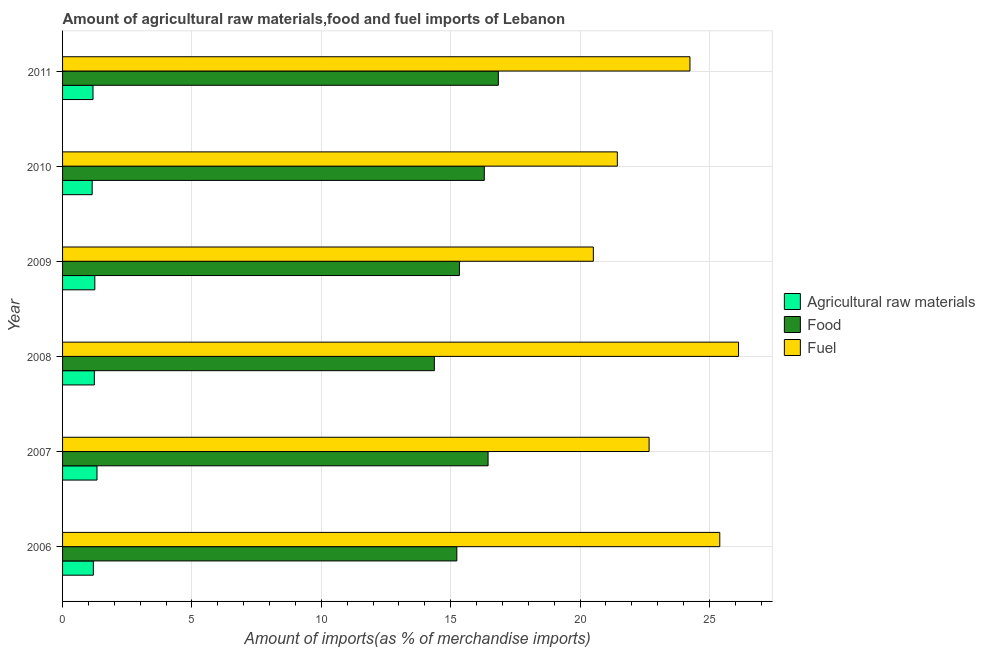How many different coloured bars are there?
Your response must be concise. 3. How many groups of bars are there?
Offer a terse response. 6. Are the number of bars on each tick of the Y-axis equal?
Offer a very short reply. Yes. How many bars are there on the 6th tick from the bottom?
Offer a very short reply. 3. What is the label of the 1st group of bars from the top?
Offer a terse response. 2011. What is the percentage of raw materials imports in 2006?
Give a very brief answer. 1.19. Across all years, what is the maximum percentage of fuel imports?
Offer a very short reply. 26.12. Across all years, what is the minimum percentage of fuel imports?
Keep it short and to the point. 20.51. What is the total percentage of food imports in the graph?
Ensure brevity in your answer.  94.52. What is the difference between the percentage of food imports in 2007 and that in 2011?
Your answer should be compact. -0.4. What is the difference between the percentage of food imports in 2006 and the percentage of raw materials imports in 2007?
Provide a succinct answer. 13.91. What is the average percentage of food imports per year?
Your answer should be very brief. 15.75. In the year 2007, what is the difference between the percentage of raw materials imports and percentage of fuel imports?
Provide a succinct answer. -21.34. What is the ratio of the percentage of food imports in 2006 to that in 2007?
Ensure brevity in your answer.  0.93. What is the difference between the highest and the second highest percentage of raw materials imports?
Give a very brief answer. 0.08. What is the difference between the highest and the lowest percentage of raw materials imports?
Make the answer very short. 0.19. In how many years, is the percentage of fuel imports greater than the average percentage of fuel imports taken over all years?
Your answer should be very brief. 3. Is the sum of the percentage of food imports in 2009 and 2011 greater than the maximum percentage of fuel imports across all years?
Keep it short and to the point. Yes. What does the 1st bar from the top in 2007 represents?
Offer a very short reply. Fuel. What does the 2nd bar from the bottom in 2007 represents?
Offer a very short reply. Food. How many bars are there?
Make the answer very short. 18. What is the difference between two consecutive major ticks on the X-axis?
Offer a terse response. 5. Does the graph contain any zero values?
Ensure brevity in your answer.  No. Does the graph contain grids?
Provide a succinct answer. Yes. How are the legend labels stacked?
Give a very brief answer. Vertical. What is the title of the graph?
Your answer should be compact. Amount of agricultural raw materials,food and fuel imports of Lebanon. Does "Negligence towards kids" appear as one of the legend labels in the graph?
Make the answer very short. No. What is the label or title of the X-axis?
Your answer should be compact. Amount of imports(as % of merchandise imports). What is the Amount of imports(as % of merchandise imports) in Agricultural raw materials in 2006?
Offer a terse response. 1.19. What is the Amount of imports(as % of merchandise imports) in Food in 2006?
Provide a short and direct response. 15.24. What is the Amount of imports(as % of merchandise imports) of Fuel in 2006?
Your answer should be compact. 25.4. What is the Amount of imports(as % of merchandise imports) of Agricultural raw materials in 2007?
Give a very brief answer. 1.33. What is the Amount of imports(as % of merchandise imports) in Food in 2007?
Offer a terse response. 16.44. What is the Amount of imports(as % of merchandise imports) of Fuel in 2007?
Offer a very short reply. 22.67. What is the Amount of imports(as % of merchandise imports) in Agricultural raw materials in 2008?
Keep it short and to the point. 1.23. What is the Amount of imports(as % of merchandise imports) in Food in 2008?
Provide a short and direct response. 14.37. What is the Amount of imports(as % of merchandise imports) in Fuel in 2008?
Keep it short and to the point. 26.12. What is the Amount of imports(as % of merchandise imports) of Agricultural raw materials in 2009?
Ensure brevity in your answer.  1.25. What is the Amount of imports(as % of merchandise imports) in Food in 2009?
Provide a succinct answer. 15.34. What is the Amount of imports(as % of merchandise imports) of Fuel in 2009?
Keep it short and to the point. 20.51. What is the Amount of imports(as % of merchandise imports) in Agricultural raw materials in 2010?
Your answer should be compact. 1.14. What is the Amount of imports(as % of merchandise imports) in Food in 2010?
Ensure brevity in your answer.  16.3. What is the Amount of imports(as % of merchandise imports) in Fuel in 2010?
Keep it short and to the point. 21.44. What is the Amount of imports(as % of merchandise imports) in Agricultural raw materials in 2011?
Keep it short and to the point. 1.18. What is the Amount of imports(as % of merchandise imports) of Food in 2011?
Ensure brevity in your answer.  16.84. What is the Amount of imports(as % of merchandise imports) of Fuel in 2011?
Your response must be concise. 24.25. Across all years, what is the maximum Amount of imports(as % of merchandise imports) in Agricultural raw materials?
Provide a short and direct response. 1.33. Across all years, what is the maximum Amount of imports(as % of merchandise imports) in Food?
Keep it short and to the point. 16.84. Across all years, what is the maximum Amount of imports(as % of merchandise imports) of Fuel?
Your response must be concise. 26.12. Across all years, what is the minimum Amount of imports(as % of merchandise imports) in Agricultural raw materials?
Provide a short and direct response. 1.14. Across all years, what is the minimum Amount of imports(as % of merchandise imports) of Food?
Make the answer very short. 14.37. Across all years, what is the minimum Amount of imports(as % of merchandise imports) of Fuel?
Provide a short and direct response. 20.51. What is the total Amount of imports(as % of merchandise imports) of Agricultural raw materials in the graph?
Provide a succinct answer. 7.32. What is the total Amount of imports(as % of merchandise imports) in Food in the graph?
Provide a succinct answer. 94.52. What is the total Amount of imports(as % of merchandise imports) in Fuel in the graph?
Offer a terse response. 140.39. What is the difference between the Amount of imports(as % of merchandise imports) of Agricultural raw materials in 2006 and that in 2007?
Make the answer very short. -0.14. What is the difference between the Amount of imports(as % of merchandise imports) in Food in 2006 and that in 2007?
Your response must be concise. -1.21. What is the difference between the Amount of imports(as % of merchandise imports) of Fuel in 2006 and that in 2007?
Make the answer very short. 2.73. What is the difference between the Amount of imports(as % of merchandise imports) in Agricultural raw materials in 2006 and that in 2008?
Your answer should be very brief. -0.04. What is the difference between the Amount of imports(as % of merchandise imports) of Food in 2006 and that in 2008?
Make the answer very short. 0.87. What is the difference between the Amount of imports(as % of merchandise imports) in Fuel in 2006 and that in 2008?
Offer a very short reply. -0.73. What is the difference between the Amount of imports(as % of merchandise imports) in Agricultural raw materials in 2006 and that in 2009?
Your answer should be compact. -0.06. What is the difference between the Amount of imports(as % of merchandise imports) of Food in 2006 and that in 2009?
Make the answer very short. -0.1. What is the difference between the Amount of imports(as % of merchandise imports) of Fuel in 2006 and that in 2009?
Keep it short and to the point. 4.89. What is the difference between the Amount of imports(as % of merchandise imports) in Agricultural raw materials in 2006 and that in 2010?
Your answer should be very brief. 0.04. What is the difference between the Amount of imports(as % of merchandise imports) in Food in 2006 and that in 2010?
Offer a terse response. -1.06. What is the difference between the Amount of imports(as % of merchandise imports) in Fuel in 2006 and that in 2010?
Your answer should be compact. 3.96. What is the difference between the Amount of imports(as % of merchandise imports) of Agricultural raw materials in 2006 and that in 2011?
Ensure brevity in your answer.  0.01. What is the difference between the Amount of imports(as % of merchandise imports) of Food in 2006 and that in 2011?
Provide a succinct answer. -1.6. What is the difference between the Amount of imports(as % of merchandise imports) in Fuel in 2006 and that in 2011?
Your response must be concise. 1.15. What is the difference between the Amount of imports(as % of merchandise imports) in Agricultural raw materials in 2007 and that in 2008?
Your answer should be very brief. 0.1. What is the difference between the Amount of imports(as % of merchandise imports) in Food in 2007 and that in 2008?
Your response must be concise. 2.08. What is the difference between the Amount of imports(as % of merchandise imports) in Fuel in 2007 and that in 2008?
Provide a succinct answer. -3.46. What is the difference between the Amount of imports(as % of merchandise imports) of Agricultural raw materials in 2007 and that in 2009?
Ensure brevity in your answer.  0.08. What is the difference between the Amount of imports(as % of merchandise imports) in Food in 2007 and that in 2009?
Keep it short and to the point. 1.11. What is the difference between the Amount of imports(as % of merchandise imports) in Fuel in 2007 and that in 2009?
Ensure brevity in your answer.  2.15. What is the difference between the Amount of imports(as % of merchandise imports) of Agricultural raw materials in 2007 and that in 2010?
Provide a short and direct response. 0.19. What is the difference between the Amount of imports(as % of merchandise imports) in Food in 2007 and that in 2010?
Provide a succinct answer. 0.15. What is the difference between the Amount of imports(as % of merchandise imports) in Fuel in 2007 and that in 2010?
Your answer should be compact. 1.23. What is the difference between the Amount of imports(as % of merchandise imports) of Agricultural raw materials in 2007 and that in 2011?
Offer a terse response. 0.15. What is the difference between the Amount of imports(as % of merchandise imports) of Food in 2007 and that in 2011?
Your answer should be compact. -0.4. What is the difference between the Amount of imports(as % of merchandise imports) in Fuel in 2007 and that in 2011?
Your answer should be very brief. -1.58. What is the difference between the Amount of imports(as % of merchandise imports) in Agricultural raw materials in 2008 and that in 2009?
Offer a very short reply. -0.02. What is the difference between the Amount of imports(as % of merchandise imports) of Food in 2008 and that in 2009?
Ensure brevity in your answer.  -0.97. What is the difference between the Amount of imports(as % of merchandise imports) in Fuel in 2008 and that in 2009?
Provide a succinct answer. 5.61. What is the difference between the Amount of imports(as % of merchandise imports) of Agricultural raw materials in 2008 and that in 2010?
Your answer should be very brief. 0.08. What is the difference between the Amount of imports(as % of merchandise imports) of Food in 2008 and that in 2010?
Provide a succinct answer. -1.93. What is the difference between the Amount of imports(as % of merchandise imports) in Fuel in 2008 and that in 2010?
Make the answer very short. 4.68. What is the difference between the Amount of imports(as % of merchandise imports) in Agricultural raw materials in 2008 and that in 2011?
Give a very brief answer. 0.05. What is the difference between the Amount of imports(as % of merchandise imports) in Food in 2008 and that in 2011?
Your answer should be compact. -2.47. What is the difference between the Amount of imports(as % of merchandise imports) in Fuel in 2008 and that in 2011?
Your answer should be compact. 1.88. What is the difference between the Amount of imports(as % of merchandise imports) of Agricultural raw materials in 2009 and that in 2010?
Provide a short and direct response. 0.1. What is the difference between the Amount of imports(as % of merchandise imports) in Food in 2009 and that in 2010?
Give a very brief answer. -0.96. What is the difference between the Amount of imports(as % of merchandise imports) in Fuel in 2009 and that in 2010?
Make the answer very short. -0.93. What is the difference between the Amount of imports(as % of merchandise imports) in Agricultural raw materials in 2009 and that in 2011?
Keep it short and to the point. 0.07. What is the difference between the Amount of imports(as % of merchandise imports) in Food in 2009 and that in 2011?
Offer a terse response. -1.5. What is the difference between the Amount of imports(as % of merchandise imports) in Fuel in 2009 and that in 2011?
Your response must be concise. -3.73. What is the difference between the Amount of imports(as % of merchandise imports) in Agricultural raw materials in 2010 and that in 2011?
Your answer should be very brief. -0.03. What is the difference between the Amount of imports(as % of merchandise imports) of Food in 2010 and that in 2011?
Provide a succinct answer. -0.54. What is the difference between the Amount of imports(as % of merchandise imports) of Fuel in 2010 and that in 2011?
Make the answer very short. -2.81. What is the difference between the Amount of imports(as % of merchandise imports) of Agricultural raw materials in 2006 and the Amount of imports(as % of merchandise imports) of Food in 2007?
Ensure brevity in your answer.  -15.26. What is the difference between the Amount of imports(as % of merchandise imports) of Agricultural raw materials in 2006 and the Amount of imports(as % of merchandise imports) of Fuel in 2007?
Provide a short and direct response. -21.48. What is the difference between the Amount of imports(as % of merchandise imports) in Food in 2006 and the Amount of imports(as % of merchandise imports) in Fuel in 2007?
Provide a succinct answer. -7.43. What is the difference between the Amount of imports(as % of merchandise imports) in Agricultural raw materials in 2006 and the Amount of imports(as % of merchandise imports) in Food in 2008?
Provide a succinct answer. -13.18. What is the difference between the Amount of imports(as % of merchandise imports) of Agricultural raw materials in 2006 and the Amount of imports(as % of merchandise imports) of Fuel in 2008?
Offer a terse response. -24.93. What is the difference between the Amount of imports(as % of merchandise imports) in Food in 2006 and the Amount of imports(as % of merchandise imports) in Fuel in 2008?
Provide a succinct answer. -10.89. What is the difference between the Amount of imports(as % of merchandise imports) in Agricultural raw materials in 2006 and the Amount of imports(as % of merchandise imports) in Food in 2009?
Your response must be concise. -14.15. What is the difference between the Amount of imports(as % of merchandise imports) of Agricultural raw materials in 2006 and the Amount of imports(as % of merchandise imports) of Fuel in 2009?
Provide a succinct answer. -19.32. What is the difference between the Amount of imports(as % of merchandise imports) in Food in 2006 and the Amount of imports(as % of merchandise imports) in Fuel in 2009?
Keep it short and to the point. -5.28. What is the difference between the Amount of imports(as % of merchandise imports) in Agricultural raw materials in 2006 and the Amount of imports(as % of merchandise imports) in Food in 2010?
Your answer should be very brief. -15.11. What is the difference between the Amount of imports(as % of merchandise imports) in Agricultural raw materials in 2006 and the Amount of imports(as % of merchandise imports) in Fuel in 2010?
Give a very brief answer. -20.25. What is the difference between the Amount of imports(as % of merchandise imports) of Food in 2006 and the Amount of imports(as % of merchandise imports) of Fuel in 2010?
Give a very brief answer. -6.2. What is the difference between the Amount of imports(as % of merchandise imports) in Agricultural raw materials in 2006 and the Amount of imports(as % of merchandise imports) in Food in 2011?
Your answer should be very brief. -15.65. What is the difference between the Amount of imports(as % of merchandise imports) of Agricultural raw materials in 2006 and the Amount of imports(as % of merchandise imports) of Fuel in 2011?
Offer a very short reply. -23.06. What is the difference between the Amount of imports(as % of merchandise imports) of Food in 2006 and the Amount of imports(as % of merchandise imports) of Fuel in 2011?
Your answer should be compact. -9.01. What is the difference between the Amount of imports(as % of merchandise imports) in Agricultural raw materials in 2007 and the Amount of imports(as % of merchandise imports) in Food in 2008?
Keep it short and to the point. -13.04. What is the difference between the Amount of imports(as % of merchandise imports) in Agricultural raw materials in 2007 and the Amount of imports(as % of merchandise imports) in Fuel in 2008?
Keep it short and to the point. -24.79. What is the difference between the Amount of imports(as % of merchandise imports) in Food in 2007 and the Amount of imports(as % of merchandise imports) in Fuel in 2008?
Give a very brief answer. -9.68. What is the difference between the Amount of imports(as % of merchandise imports) in Agricultural raw materials in 2007 and the Amount of imports(as % of merchandise imports) in Food in 2009?
Offer a terse response. -14.01. What is the difference between the Amount of imports(as % of merchandise imports) of Agricultural raw materials in 2007 and the Amount of imports(as % of merchandise imports) of Fuel in 2009?
Ensure brevity in your answer.  -19.18. What is the difference between the Amount of imports(as % of merchandise imports) of Food in 2007 and the Amount of imports(as % of merchandise imports) of Fuel in 2009?
Keep it short and to the point. -4.07. What is the difference between the Amount of imports(as % of merchandise imports) in Agricultural raw materials in 2007 and the Amount of imports(as % of merchandise imports) in Food in 2010?
Provide a succinct answer. -14.97. What is the difference between the Amount of imports(as % of merchandise imports) of Agricultural raw materials in 2007 and the Amount of imports(as % of merchandise imports) of Fuel in 2010?
Offer a terse response. -20.11. What is the difference between the Amount of imports(as % of merchandise imports) in Food in 2007 and the Amount of imports(as % of merchandise imports) in Fuel in 2010?
Ensure brevity in your answer.  -5. What is the difference between the Amount of imports(as % of merchandise imports) in Agricultural raw materials in 2007 and the Amount of imports(as % of merchandise imports) in Food in 2011?
Make the answer very short. -15.51. What is the difference between the Amount of imports(as % of merchandise imports) in Agricultural raw materials in 2007 and the Amount of imports(as % of merchandise imports) in Fuel in 2011?
Your answer should be very brief. -22.92. What is the difference between the Amount of imports(as % of merchandise imports) of Food in 2007 and the Amount of imports(as % of merchandise imports) of Fuel in 2011?
Make the answer very short. -7.8. What is the difference between the Amount of imports(as % of merchandise imports) in Agricultural raw materials in 2008 and the Amount of imports(as % of merchandise imports) in Food in 2009?
Your answer should be compact. -14.11. What is the difference between the Amount of imports(as % of merchandise imports) of Agricultural raw materials in 2008 and the Amount of imports(as % of merchandise imports) of Fuel in 2009?
Ensure brevity in your answer.  -19.28. What is the difference between the Amount of imports(as % of merchandise imports) of Food in 2008 and the Amount of imports(as % of merchandise imports) of Fuel in 2009?
Provide a succinct answer. -6.14. What is the difference between the Amount of imports(as % of merchandise imports) in Agricultural raw materials in 2008 and the Amount of imports(as % of merchandise imports) in Food in 2010?
Make the answer very short. -15.07. What is the difference between the Amount of imports(as % of merchandise imports) in Agricultural raw materials in 2008 and the Amount of imports(as % of merchandise imports) in Fuel in 2010?
Provide a succinct answer. -20.21. What is the difference between the Amount of imports(as % of merchandise imports) of Food in 2008 and the Amount of imports(as % of merchandise imports) of Fuel in 2010?
Your response must be concise. -7.07. What is the difference between the Amount of imports(as % of merchandise imports) of Agricultural raw materials in 2008 and the Amount of imports(as % of merchandise imports) of Food in 2011?
Your answer should be compact. -15.61. What is the difference between the Amount of imports(as % of merchandise imports) of Agricultural raw materials in 2008 and the Amount of imports(as % of merchandise imports) of Fuel in 2011?
Your response must be concise. -23.02. What is the difference between the Amount of imports(as % of merchandise imports) of Food in 2008 and the Amount of imports(as % of merchandise imports) of Fuel in 2011?
Ensure brevity in your answer.  -9.88. What is the difference between the Amount of imports(as % of merchandise imports) of Agricultural raw materials in 2009 and the Amount of imports(as % of merchandise imports) of Food in 2010?
Ensure brevity in your answer.  -15.05. What is the difference between the Amount of imports(as % of merchandise imports) in Agricultural raw materials in 2009 and the Amount of imports(as % of merchandise imports) in Fuel in 2010?
Offer a very short reply. -20.19. What is the difference between the Amount of imports(as % of merchandise imports) in Food in 2009 and the Amount of imports(as % of merchandise imports) in Fuel in 2010?
Make the answer very short. -6.1. What is the difference between the Amount of imports(as % of merchandise imports) in Agricultural raw materials in 2009 and the Amount of imports(as % of merchandise imports) in Food in 2011?
Make the answer very short. -15.59. What is the difference between the Amount of imports(as % of merchandise imports) of Agricultural raw materials in 2009 and the Amount of imports(as % of merchandise imports) of Fuel in 2011?
Your answer should be compact. -23. What is the difference between the Amount of imports(as % of merchandise imports) in Food in 2009 and the Amount of imports(as % of merchandise imports) in Fuel in 2011?
Make the answer very short. -8.91. What is the difference between the Amount of imports(as % of merchandise imports) in Agricultural raw materials in 2010 and the Amount of imports(as % of merchandise imports) in Food in 2011?
Keep it short and to the point. -15.7. What is the difference between the Amount of imports(as % of merchandise imports) of Agricultural raw materials in 2010 and the Amount of imports(as % of merchandise imports) of Fuel in 2011?
Your answer should be compact. -23.1. What is the difference between the Amount of imports(as % of merchandise imports) of Food in 2010 and the Amount of imports(as % of merchandise imports) of Fuel in 2011?
Your answer should be compact. -7.95. What is the average Amount of imports(as % of merchandise imports) in Agricultural raw materials per year?
Offer a terse response. 1.22. What is the average Amount of imports(as % of merchandise imports) in Food per year?
Your response must be concise. 15.75. What is the average Amount of imports(as % of merchandise imports) of Fuel per year?
Provide a short and direct response. 23.4. In the year 2006, what is the difference between the Amount of imports(as % of merchandise imports) in Agricultural raw materials and Amount of imports(as % of merchandise imports) in Food?
Provide a succinct answer. -14.05. In the year 2006, what is the difference between the Amount of imports(as % of merchandise imports) of Agricultural raw materials and Amount of imports(as % of merchandise imports) of Fuel?
Your answer should be very brief. -24.21. In the year 2006, what is the difference between the Amount of imports(as % of merchandise imports) in Food and Amount of imports(as % of merchandise imports) in Fuel?
Ensure brevity in your answer.  -10.16. In the year 2007, what is the difference between the Amount of imports(as % of merchandise imports) of Agricultural raw materials and Amount of imports(as % of merchandise imports) of Food?
Provide a short and direct response. -15.11. In the year 2007, what is the difference between the Amount of imports(as % of merchandise imports) in Agricultural raw materials and Amount of imports(as % of merchandise imports) in Fuel?
Offer a very short reply. -21.34. In the year 2007, what is the difference between the Amount of imports(as % of merchandise imports) of Food and Amount of imports(as % of merchandise imports) of Fuel?
Offer a terse response. -6.22. In the year 2008, what is the difference between the Amount of imports(as % of merchandise imports) in Agricultural raw materials and Amount of imports(as % of merchandise imports) in Food?
Give a very brief answer. -13.14. In the year 2008, what is the difference between the Amount of imports(as % of merchandise imports) in Agricultural raw materials and Amount of imports(as % of merchandise imports) in Fuel?
Ensure brevity in your answer.  -24.9. In the year 2008, what is the difference between the Amount of imports(as % of merchandise imports) of Food and Amount of imports(as % of merchandise imports) of Fuel?
Offer a terse response. -11.76. In the year 2009, what is the difference between the Amount of imports(as % of merchandise imports) of Agricultural raw materials and Amount of imports(as % of merchandise imports) of Food?
Ensure brevity in your answer.  -14.09. In the year 2009, what is the difference between the Amount of imports(as % of merchandise imports) in Agricultural raw materials and Amount of imports(as % of merchandise imports) in Fuel?
Offer a terse response. -19.27. In the year 2009, what is the difference between the Amount of imports(as % of merchandise imports) of Food and Amount of imports(as % of merchandise imports) of Fuel?
Give a very brief answer. -5.18. In the year 2010, what is the difference between the Amount of imports(as % of merchandise imports) of Agricultural raw materials and Amount of imports(as % of merchandise imports) of Food?
Ensure brevity in your answer.  -15.15. In the year 2010, what is the difference between the Amount of imports(as % of merchandise imports) in Agricultural raw materials and Amount of imports(as % of merchandise imports) in Fuel?
Offer a terse response. -20.3. In the year 2010, what is the difference between the Amount of imports(as % of merchandise imports) in Food and Amount of imports(as % of merchandise imports) in Fuel?
Offer a terse response. -5.14. In the year 2011, what is the difference between the Amount of imports(as % of merchandise imports) in Agricultural raw materials and Amount of imports(as % of merchandise imports) in Food?
Provide a succinct answer. -15.66. In the year 2011, what is the difference between the Amount of imports(as % of merchandise imports) in Agricultural raw materials and Amount of imports(as % of merchandise imports) in Fuel?
Offer a terse response. -23.07. In the year 2011, what is the difference between the Amount of imports(as % of merchandise imports) of Food and Amount of imports(as % of merchandise imports) of Fuel?
Provide a succinct answer. -7.41. What is the ratio of the Amount of imports(as % of merchandise imports) in Agricultural raw materials in 2006 to that in 2007?
Make the answer very short. 0.89. What is the ratio of the Amount of imports(as % of merchandise imports) in Food in 2006 to that in 2007?
Provide a succinct answer. 0.93. What is the ratio of the Amount of imports(as % of merchandise imports) of Fuel in 2006 to that in 2007?
Provide a short and direct response. 1.12. What is the ratio of the Amount of imports(as % of merchandise imports) of Agricultural raw materials in 2006 to that in 2008?
Keep it short and to the point. 0.97. What is the ratio of the Amount of imports(as % of merchandise imports) in Food in 2006 to that in 2008?
Ensure brevity in your answer.  1.06. What is the ratio of the Amount of imports(as % of merchandise imports) of Fuel in 2006 to that in 2008?
Make the answer very short. 0.97. What is the ratio of the Amount of imports(as % of merchandise imports) in Agricultural raw materials in 2006 to that in 2009?
Offer a terse response. 0.95. What is the ratio of the Amount of imports(as % of merchandise imports) in Food in 2006 to that in 2009?
Your response must be concise. 0.99. What is the ratio of the Amount of imports(as % of merchandise imports) in Fuel in 2006 to that in 2009?
Give a very brief answer. 1.24. What is the ratio of the Amount of imports(as % of merchandise imports) in Agricultural raw materials in 2006 to that in 2010?
Keep it short and to the point. 1.04. What is the ratio of the Amount of imports(as % of merchandise imports) of Food in 2006 to that in 2010?
Ensure brevity in your answer.  0.93. What is the ratio of the Amount of imports(as % of merchandise imports) of Fuel in 2006 to that in 2010?
Provide a short and direct response. 1.18. What is the ratio of the Amount of imports(as % of merchandise imports) in Agricultural raw materials in 2006 to that in 2011?
Provide a succinct answer. 1.01. What is the ratio of the Amount of imports(as % of merchandise imports) of Food in 2006 to that in 2011?
Offer a terse response. 0.9. What is the ratio of the Amount of imports(as % of merchandise imports) in Fuel in 2006 to that in 2011?
Your response must be concise. 1.05. What is the ratio of the Amount of imports(as % of merchandise imports) of Agricultural raw materials in 2007 to that in 2008?
Provide a short and direct response. 1.08. What is the ratio of the Amount of imports(as % of merchandise imports) of Food in 2007 to that in 2008?
Offer a very short reply. 1.14. What is the ratio of the Amount of imports(as % of merchandise imports) of Fuel in 2007 to that in 2008?
Your response must be concise. 0.87. What is the ratio of the Amount of imports(as % of merchandise imports) in Agricultural raw materials in 2007 to that in 2009?
Keep it short and to the point. 1.07. What is the ratio of the Amount of imports(as % of merchandise imports) of Food in 2007 to that in 2009?
Keep it short and to the point. 1.07. What is the ratio of the Amount of imports(as % of merchandise imports) of Fuel in 2007 to that in 2009?
Ensure brevity in your answer.  1.1. What is the ratio of the Amount of imports(as % of merchandise imports) in Agricultural raw materials in 2007 to that in 2010?
Keep it short and to the point. 1.16. What is the ratio of the Amount of imports(as % of merchandise imports) in Fuel in 2007 to that in 2010?
Offer a very short reply. 1.06. What is the ratio of the Amount of imports(as % of merchandise imports) of Agricultural raw materials in 2007 to that in 2011?
Give a very brief answer. 1.13. What is the ratio of the Amount of imports(as % of merchandise imports) in Food in 2007 to that in 2011?
Ensure brevity in your answer.  0.98. What is the ratio of the Amount of imports(as % of merchandise imports) of Fuel in 2007 to that in 2011?
Give a very brief answer. 0.93. What is the ratio of the Amount of imports(as % of merchandise imports) in Agricultural raw materials in 2008 to that in 2009?
Ensure brevity in your answer.  0.99. What is the ratio of the Amount of imports(as % of merchandise imports) in Food in 2008 to that in 2009?
Make the answer very short. 0.94. What is the ratio of the Amount of imports(as % of merchandise imports) in Fuel in 2008 to that in 2009?
Keep it short and to the point. 1.27. What is the ratio of the Amount of imports(as % of merchandise imports) of Agricultural raw materials in 2008 to that in 2010?
Your answer should be very brief. 1.07. What is the ratio of the Amount of imports(as % of merchandise imports) in Food in 2008 to that in 2010?
Give a very brief answer. 0.88. What is the ratio of the Amount of imports(as % of merchandise imports) of Fuel in 2008 to that in 2010?
Provide a short and direct response. 1.22. What is the ratio of the Amount of imports(as % of merchandise imports) in Agricultural raw materials in 2008 to that in 2011?
Offer a terse response. 1.04. What is the ratio of the Amount of imports(as % of merchandise imports) of Food in 2008 to that in 2011?
Give a very brief answer. 0.85. What is the ratio of the Amount of imports(as % of merchandise imports) in Fuel in 2008 to that in 2011?
Keep it short and to the point. 1.08. What is the ratio of the Amount of imports(as % of merchandise imports) in Agricultural raw materials in 2009 to that in 2010?
Ensure brevity in your answer.  1.09. What is the ratio of the Amount of imports(as % of merchandise imports) of Food in 2009 to that in 2010?
Keep it short and to the point. 0.94. What is the ratio of the Amount of imports(as % of merchandise imports) of Fuel in 2009 to that in 2010?
Provide a succinct answer. 0.96. What is the ratio of the Amount of imports(as % of merchandise imports) of Agricultural raw materials in 2009 to that in 2011?
Provide a short and direct response. 1.06. What is the ratio of the Amount of imports(as % of merchandise imports) in Food in 2009 to that in 2011?
Offer a very short reply. 0.91. What is the ratio of the Amount of imports(as % of merchandise imports) of Fuel in 2009 to that in 2011?
Provide a short and direct response. 0.85. What is the ratio of the Amount of imports(as % of merchandise imports) in Agricultural raw materials in 2010 to that in 2011?
Provide a short and direct response. 0.97. What is the ratio of the Amount of imports(as % of merchandise imports) of Food in 2010 to that in 2011?
Provide a short and direct response. 0.97. What is the ratio of the Amount of imports(as % of merchandise imports) in Fuel in 2010 to that in 2011?
Offer a very short reply. 0.88. What is the difference between the highest and the second highest Amount of imports(as % of merchandise imports) in Agricultural raw materials?
Your answer should be very brief. 0.08. What is the difference between the highest and the second highest Amount of imports(as % of merchandise imports) of Food?
Keep it short and to the point. 0.4. What is the difference between the highest and the second highest Amount of imports(as % of merchandise imports) of Fuel?
Offer a very short reply. 0.73. What is the difference between the highest and the lowest Amount of imports(as % of merchandise imports) in Agricultural raw materials?
Keep it short and to the point. 0.19. What is the difference between the highest and the lowest Amount of imports(as % of merchandise imports) in Food?
Offer a terse response. 2.47. What is the difference between the highest and the lowest Amount of imports(as % of merchandise imports) in Fuel?
Keep it short and to the point. 5.61. 